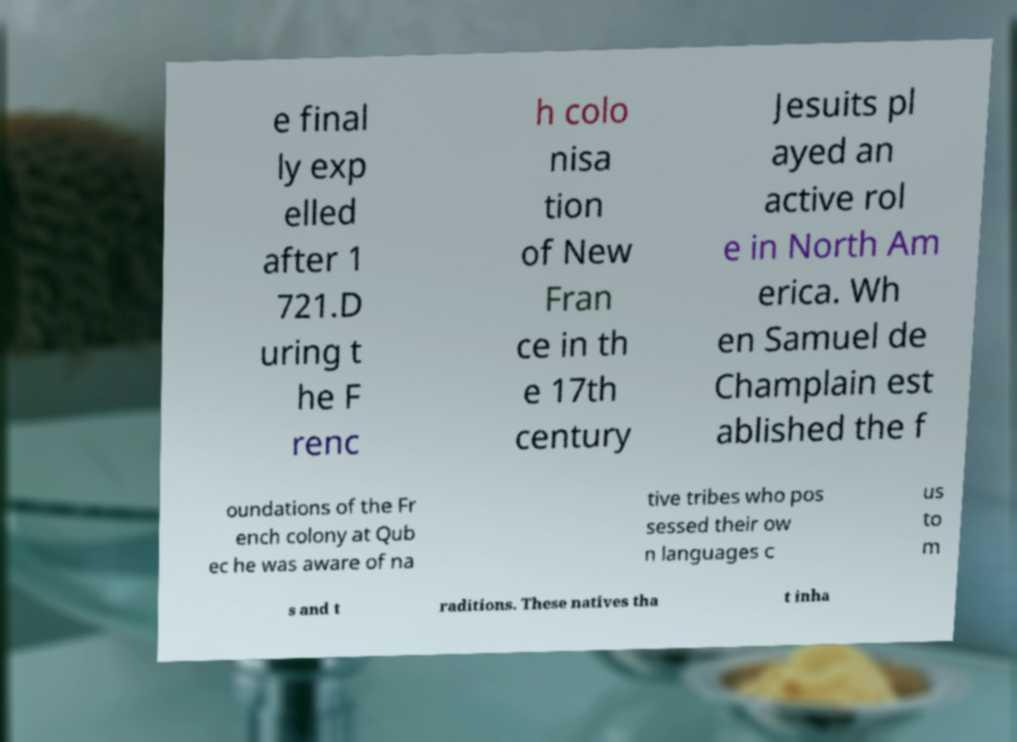For documentation purposes, I need the text within this image transcribed. Could you provide that? e final ly exp elled after 1 721.D uring t he F renc h colo nisa tion of New Fran ce in th e 17th century Jesuits pl ayed an active rol e in North Am erica. Wh en Samuel de Champlain est ablished the f oundations of the Fr ench colony at Qub ec he was aware of na tive tribes who pos sessed their ow n languages c us to m s and t raditions. These natives tha t inha 